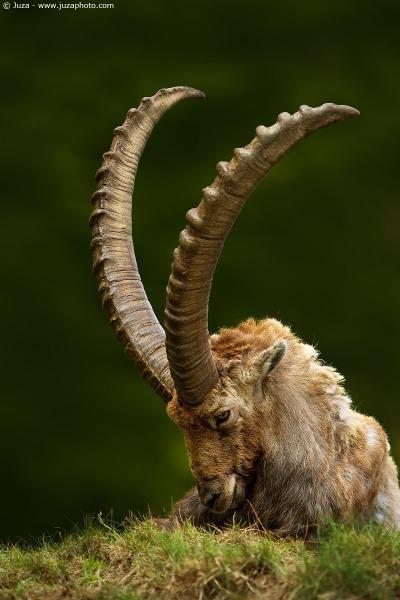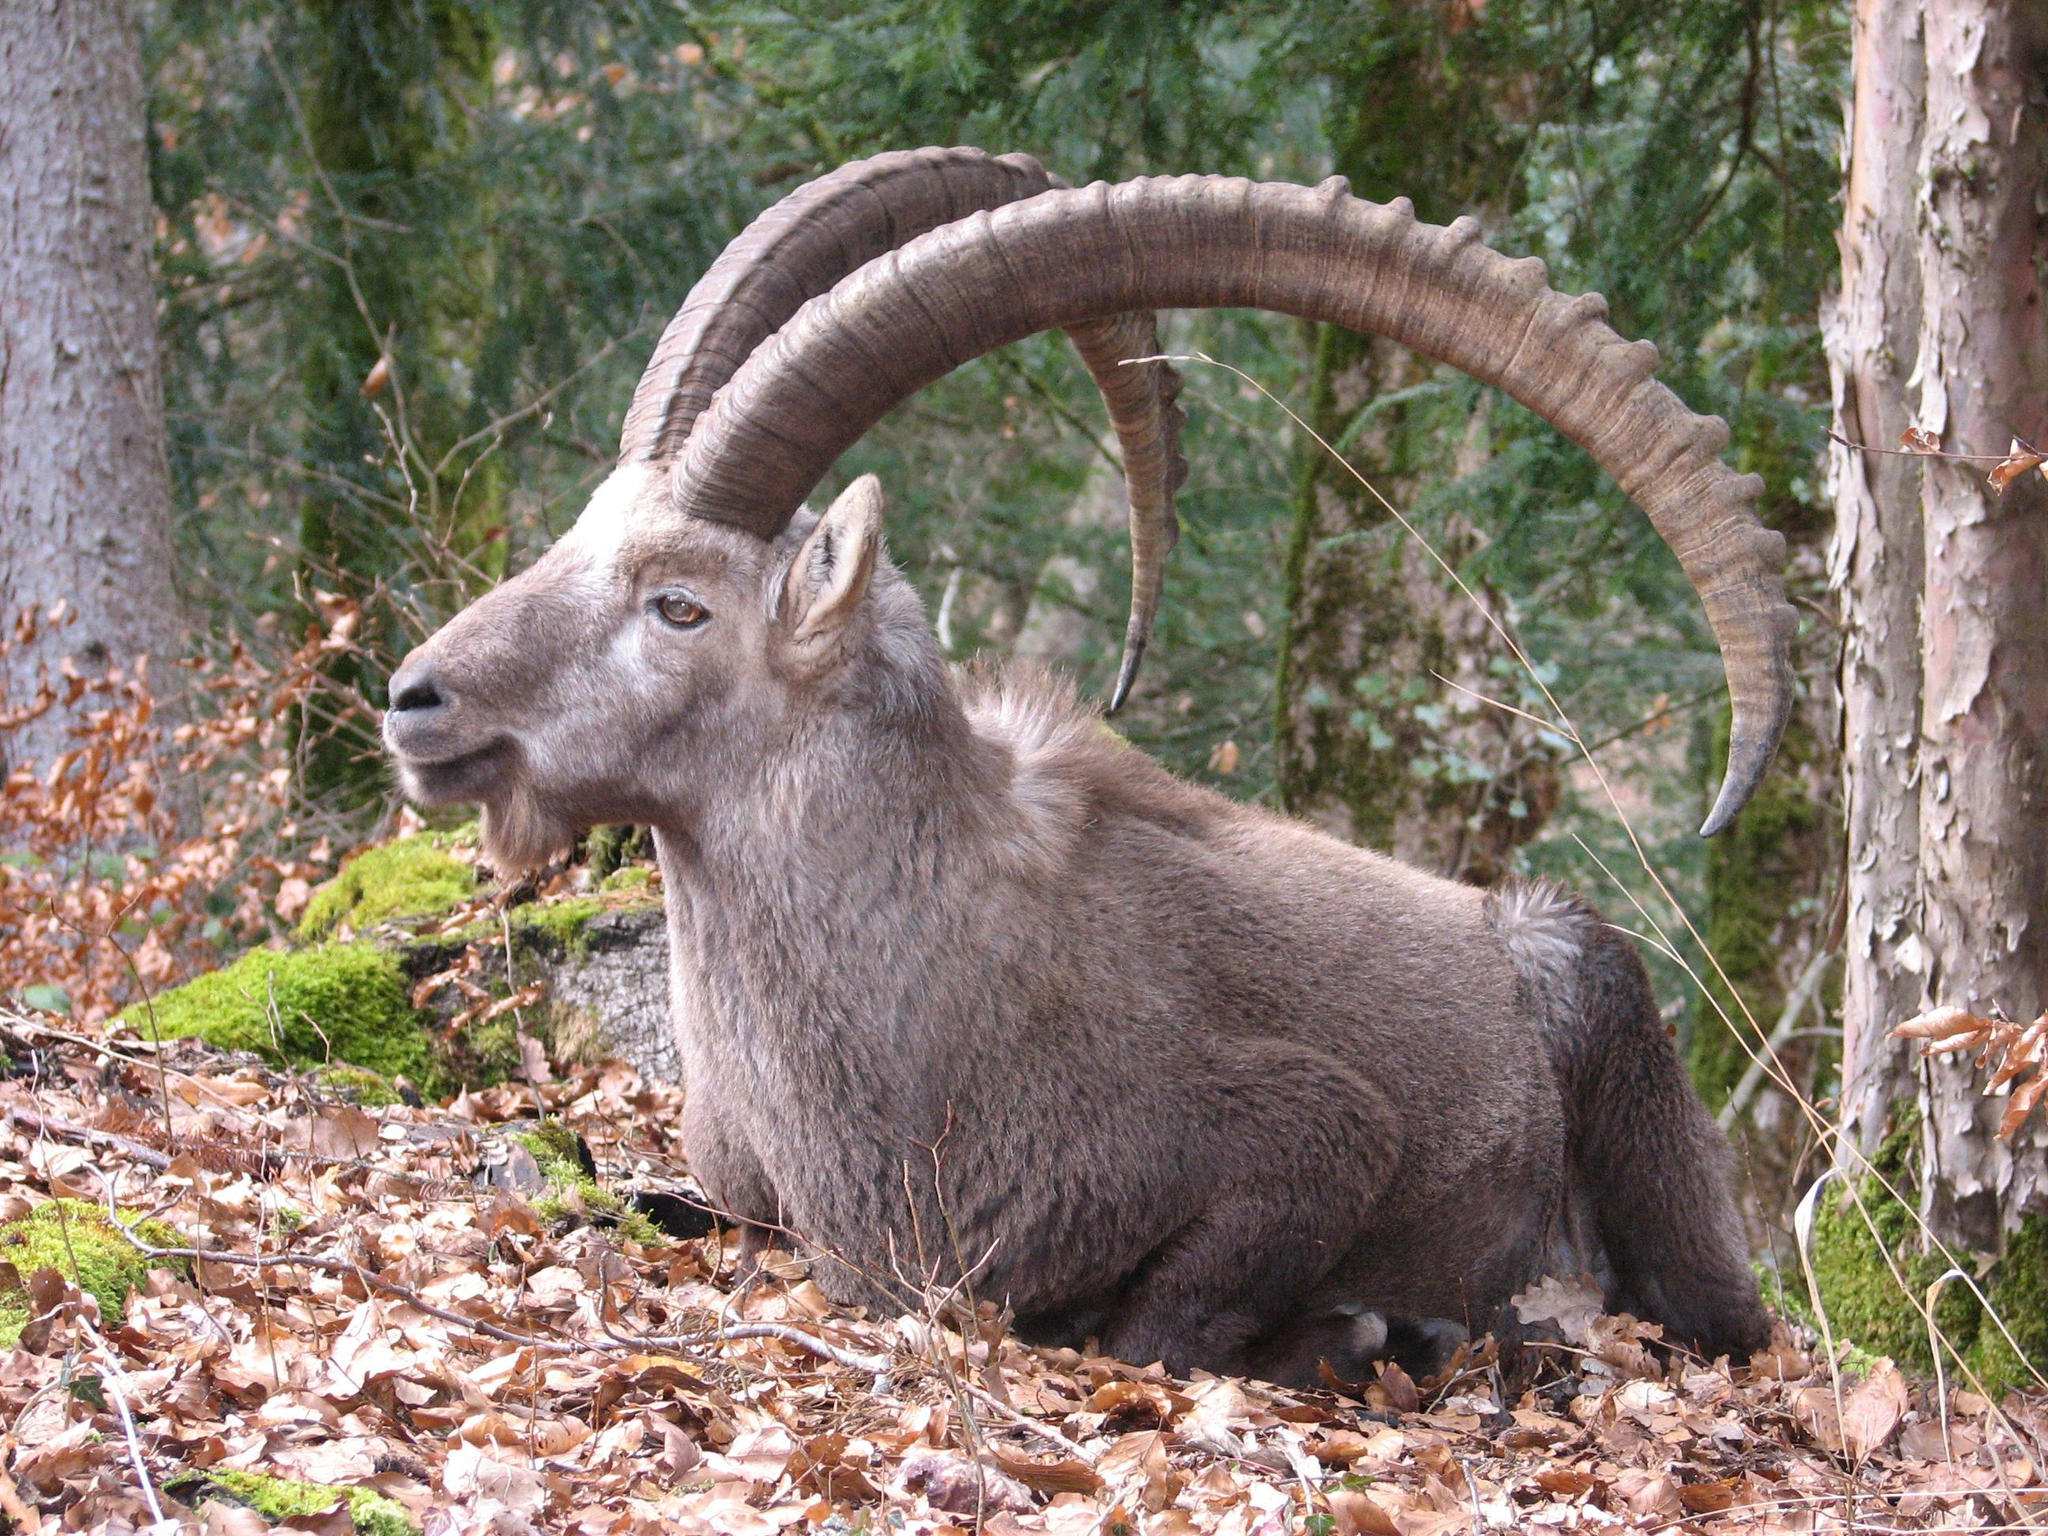The first image is the image on the left, the second image is the image on the right. Considering the images on both sides, is "One goat has its head down to the grass, while another goat is looking straight ahead." valid? Answer yes or no. Yes. The first image is the image on the left, the second image is the image on the right. Assess this claim about the two images: "The horned animals in the right and left images face the same general direction, and at least one animal is reclining on the ground.". Correct or not? Answer yes or no. Yes. 